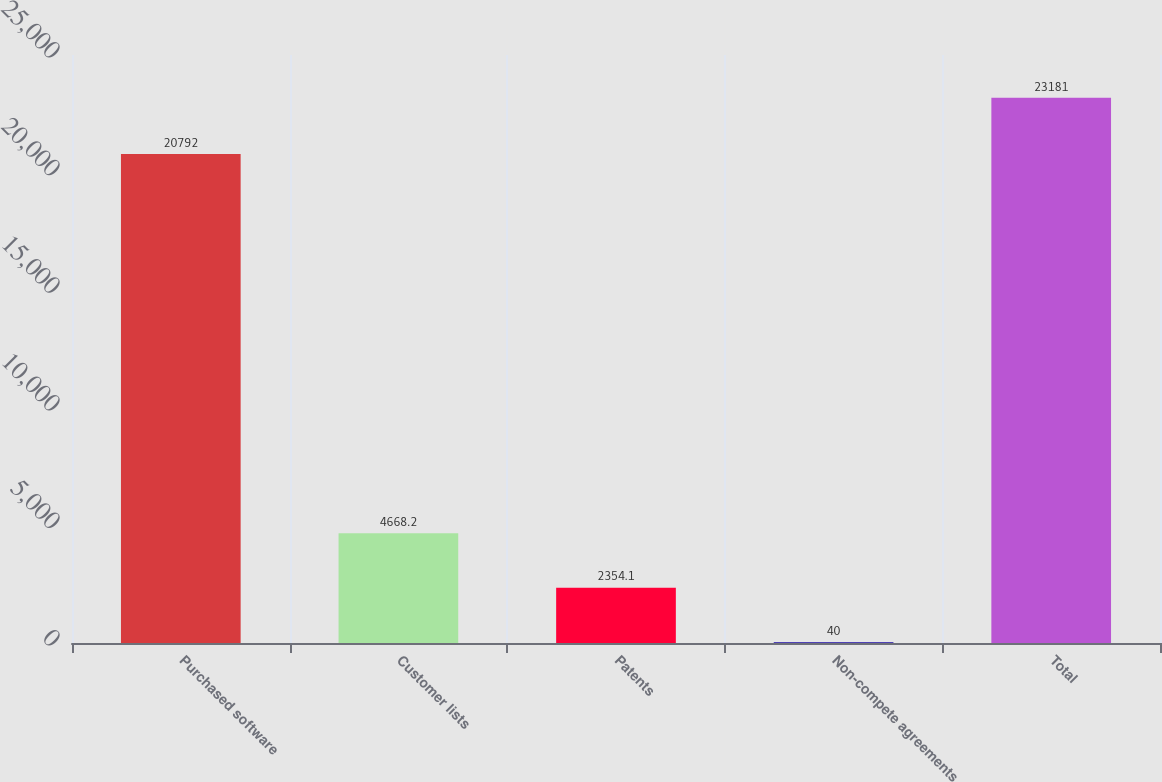Convert chart to OTSL. <chart><loc_0><loc_0><loc_500><loc_500><bar_chart><fcel>Purchased software<fcel>Customer lists<fcel>Patents<fcel>Non-compete agreements<fcel>Total<nl><fcel>20792<fcel>4668.2<fcel>2354.1<fcel>40<fcel>23181<nl></chart> 